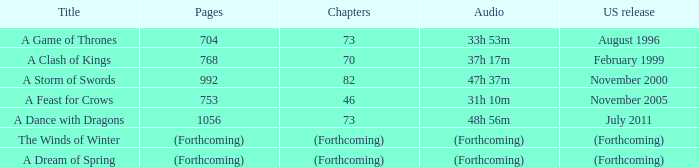Which title has a us launch in august 1996? A Game of Thrones. 